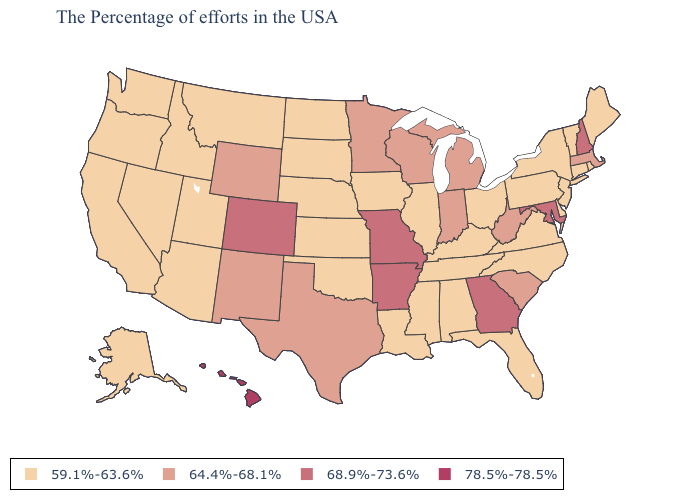Is the legend a continuous bar?
Be succinct. No. Name the states that have a value in the range 64.4%-68.1%?
Keep it brief. Massachusetts, South Carolina, West Virginia, Michigan, Indiana, Wisconsin, Minnesota, Texas, Wyoming, New Mexico. What is the highest value in the West ?
Write a very short answer. 78.5%-78.5%. What is the value of Wisconsin?
Answer briefly. 64.4%-68.1%. Which states have the highest value in the USA?
Answer briefly. Hawaii. Is the legend a continuous bar?
Short answer required. No. Does Kentucky have the lowest value in the South?
Answer briefly. Yes. How many symbols are there in the legend?
Be succinct. 4. Name the states that have a value in the range 64.4%-68.1%?
Write a very short answer. Massachusetts, South Carolina, West Virginia, Michigan, Indiana, Wisconsin, Minnesota, Texas, Wyoming, New Mexico. Which states have the lowest value in the South?
Keep it brief. Delaware, Virginia, North Carolina, Florida, Kentucky, Alabama, Tennessee, Mississippi, Louisiana, Oklahoma. Among the states that border Kansas , which have the lowest value?
Short answer required. Nebraska, Oklahoma. Which states hav the highest value in the South?
Quick response, please. Maryland, Georgia, Arkansas. What is the value of Nebraska?
Be succinct. 59.1%-63.6%. Name the states that have a value in the range 64.4%-68.1%?
Write a very short answer. Massachusetts, South Carolina, West Virginia, Michigan, Indiana, Wisconsin, Minnesota, Texas, Wyoming, New Mexico. 